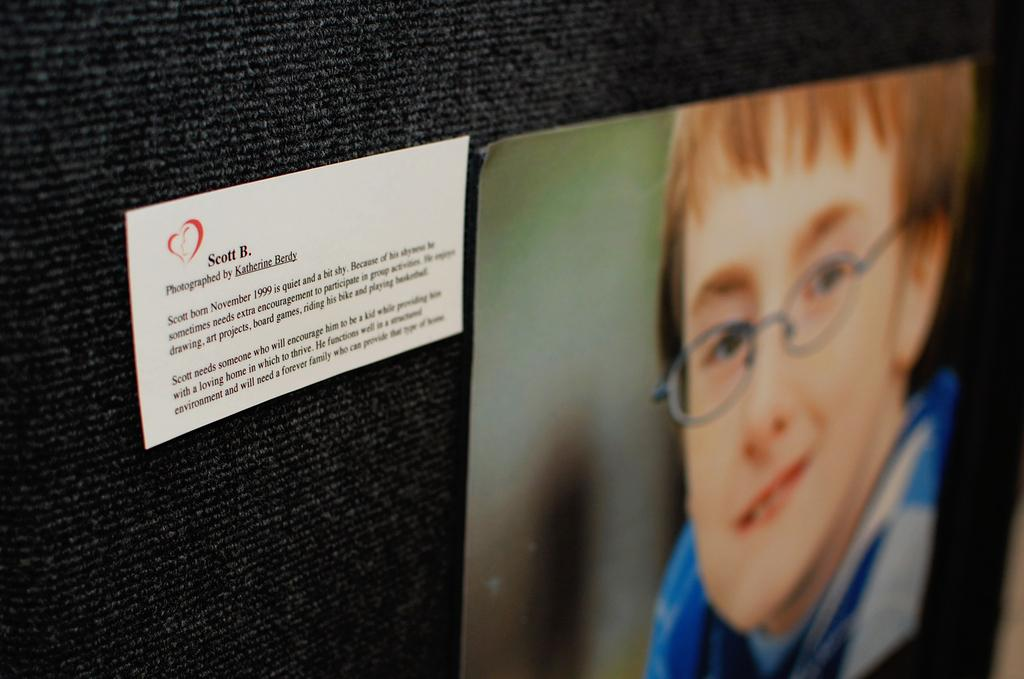What is the main object in the image? There is a card in the image. What can be found on the card? The card has text on it and a photo of a person. How is the card positioned in the image? The card is attached to a black cloth. How many cakes are displayed under the card in the image? There are no cakes present in the image. What type of roll is visible next to the card in the image? There is no roll present in the image. 